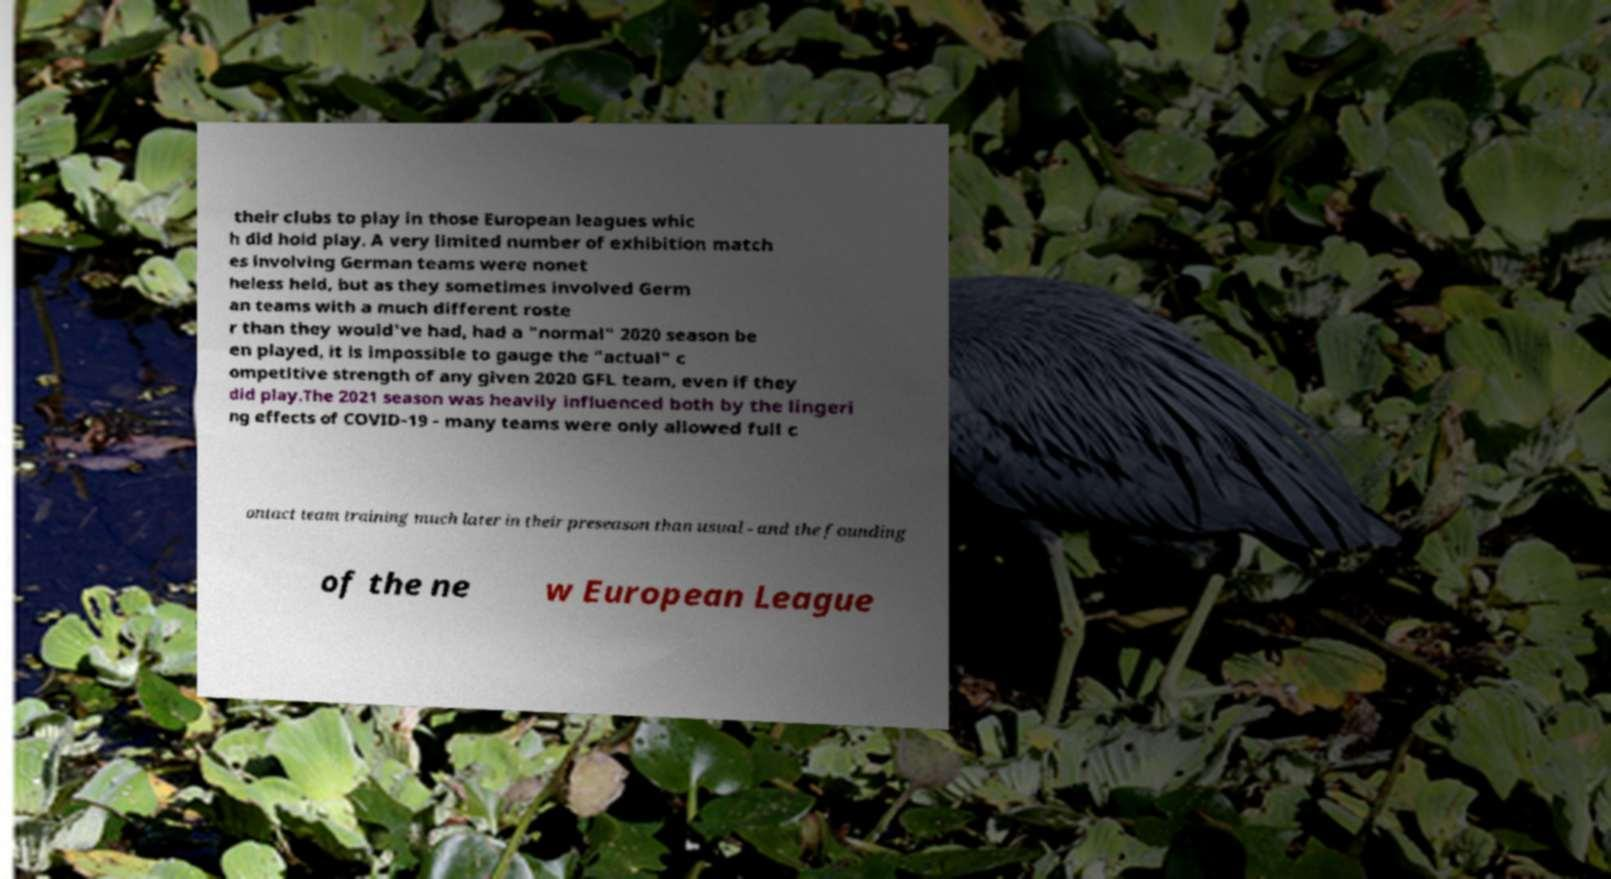For documentation purposes, I need the text within this image transcribed. Could you provide that? their clubs to play in those European leagues whic h did hold play. A very limited number of exhibition match es involving German teams were nonet heless held, but as they sometimes involved Germ an teams with a much different roste r than they would've had, had a "normal" 2020 season be en played, it is impossible to gauge the "actual" c ompetitive strength of any given 2020 GFL team, even if they did play.The 2021 season was heavily influenced both by the lingeri ng effects of COVID-19 - many teams were only allowed full c ontact team training much later in their preseason than usual - and the founding of the ne w European League 